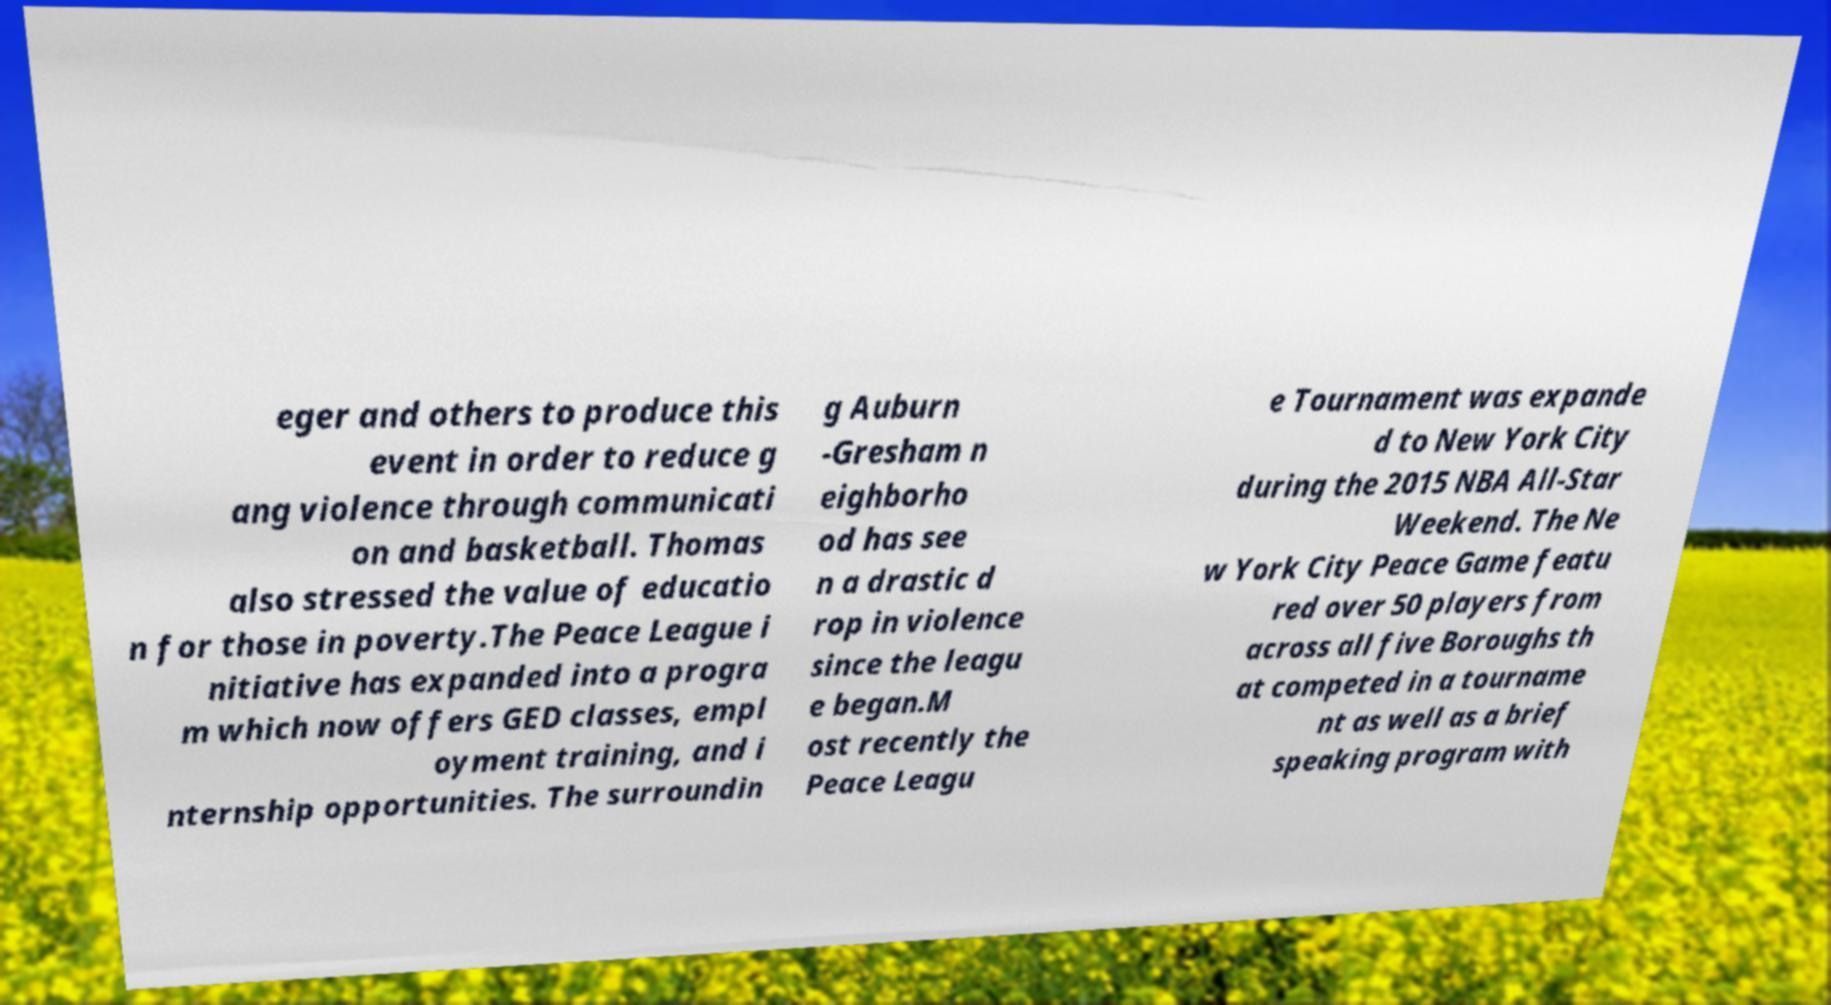Could you extract and type out the text from this image? eger and others to produce this event in order to reduce g ang violence through communicati on and basketball. Thomas also stressed the value of educatio n for those in poverty.The Peace League i nitiative has expanded into a progra m which now offers GED classes, empl oyment training, and i nternship opportunities. The surroundin g Auburn -Gresham n eighborho od has see n a drastic d rop in violence since the leagu e began.M ost recently the Peace Leagu e Tournament was expande d to New York City during the 2015 NBA All-Star Weekend. The Ne w York City Peace Game featu red over 50 players from across all five Boroughs th at competed in a tourname nt as well as a brief speaking program with 